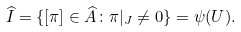Convert formula to latex. <formula><loc_0><loc_0><loc_500><loc_500>\widehat { I } = \{ [ \pi ] \in \widehat { A } \colon \pi | _ { J } \neq 0 \} = \psi ( U ) .</formula> 